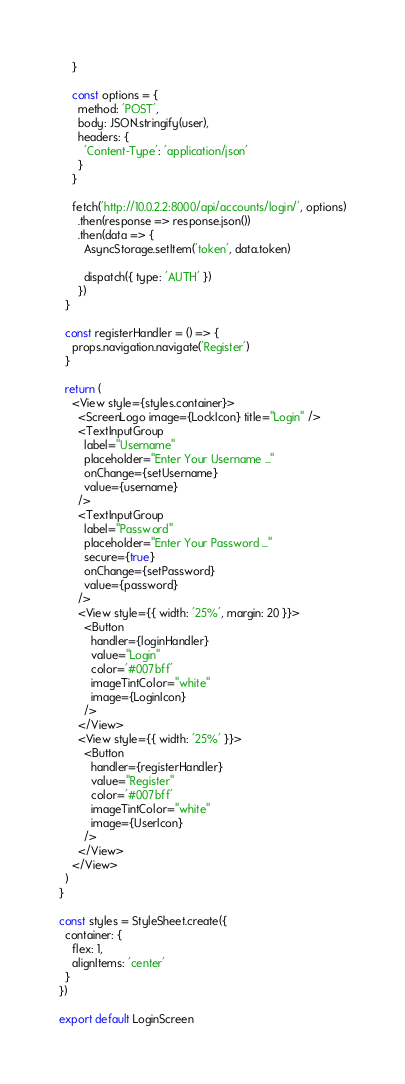<code> <loc_0><loc_0><loc_500><loc_500><_JavaScript_>    }

    const options = {
      method: 'POST',
      body: JSON.stringify(user),
      headers: {
        'Content-Type': 'application/json'
      }
    }

    fetch('http://10.0.2.2:8000/api/accounts/login/', options)
      .then(response => response.json())
      .then(data => {
        AsyncStorage.setItem('token', data.token)

        dispatch({ type: 'AUTH' })
      })
  }

  const registerHandler = () => {
    props.navigation.navigate('Register')
  }

  return (
    <View style={styles.container}>
      <ScreenLogo image={LockIcon} title="Login" />
      <TextInputGroup
        label="Username"
        placeholder="Enter Your Username ..."
        onChange={setUsername}
        value={username}
      />
      <TextInputGroup
        label="Password"
        placeholder="Enter Your Password ..."
        secure={true}
        onChange={setPassword}
        value={password}
      />
      <View style={{ width: '25%', margin: 20 }}>
        <Button
          handler={loginHandler}
          value="Login"
          color='#007bff'
          imageTintColor="white"
          image={LoginIcon}
        />
      </View>
      <View style={{ width: '25%' }}>
        <Button
          handler={registerHandler}
          value="Register"
          color='#007bff'
          imageTintColor="white"
          image={UserIcon}
        />
      </View>
    </View>
  )
}

const styles = StyleSheet.create({
  container: {
    flex: 1,
    alignItems: 'center'
  }
})

export default LoginScreen</code> 